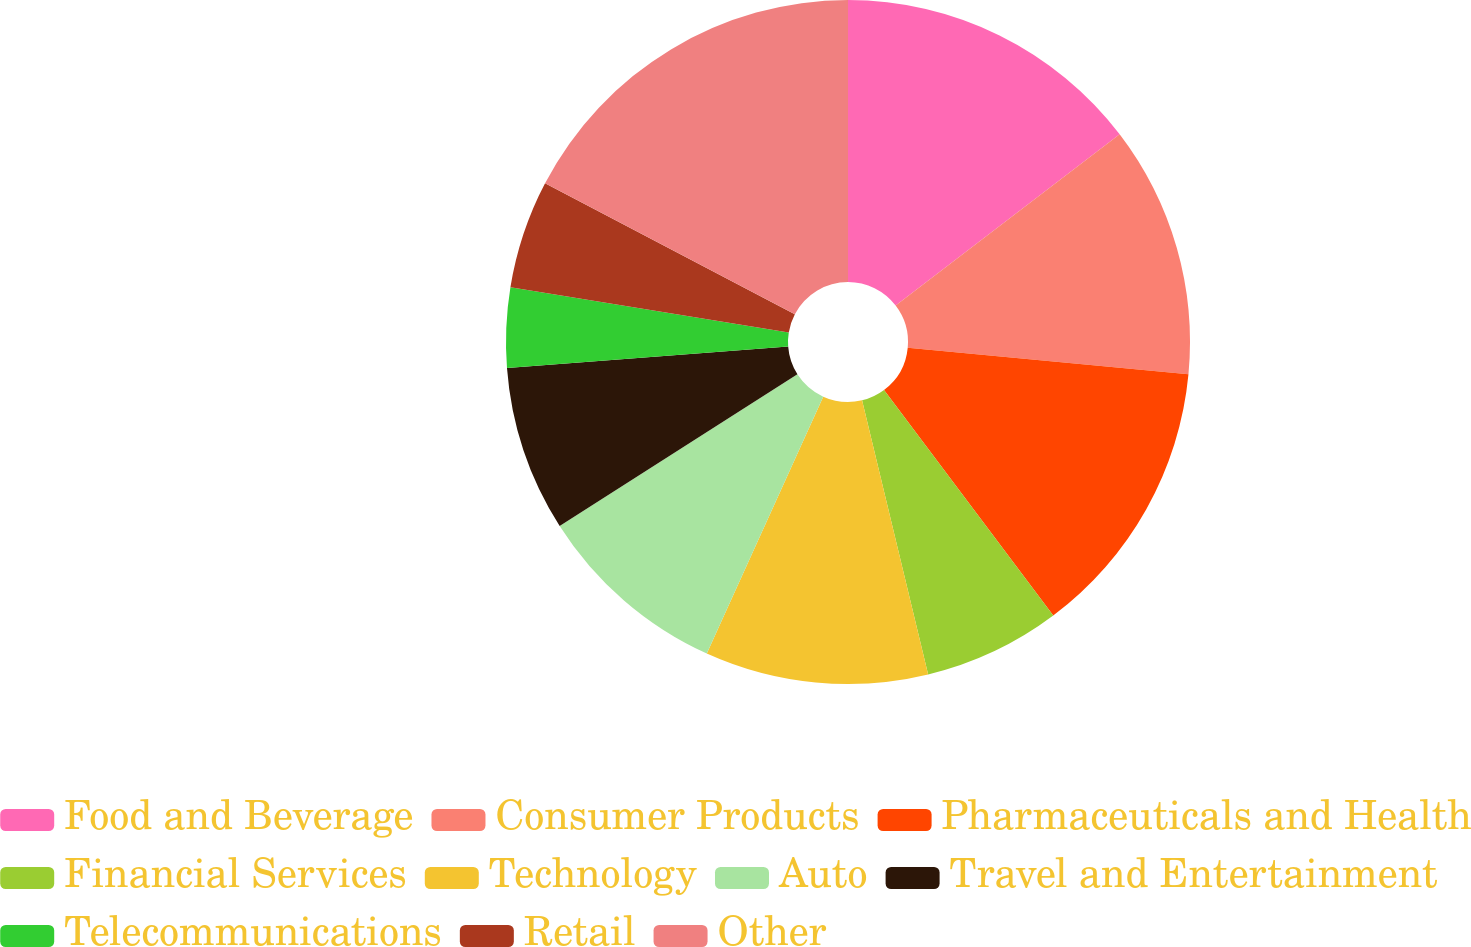Convert chart. <chart><loc_0><loc_0><loc_500><loc_500><pie_chart><fcel>Food and Beverage<fcel>Consumer Products<fcel>Pharmaceuticals and Health<fcel>Financial Services<fcel>Technology<fcel>Auto<fcel>Travel and Entertainment<fcel>Telecommunications<fcel>Retail<fcel>Other<nl><fcel>14.61%<fcel>11.9%<fcel>13.25%<fcel>6.48%<fcel>10.54%<fcel>9.19%<fcel>7.83%<fcel>3.77%<fcel>5.12%<fcel>17.32%<nl></chart> 